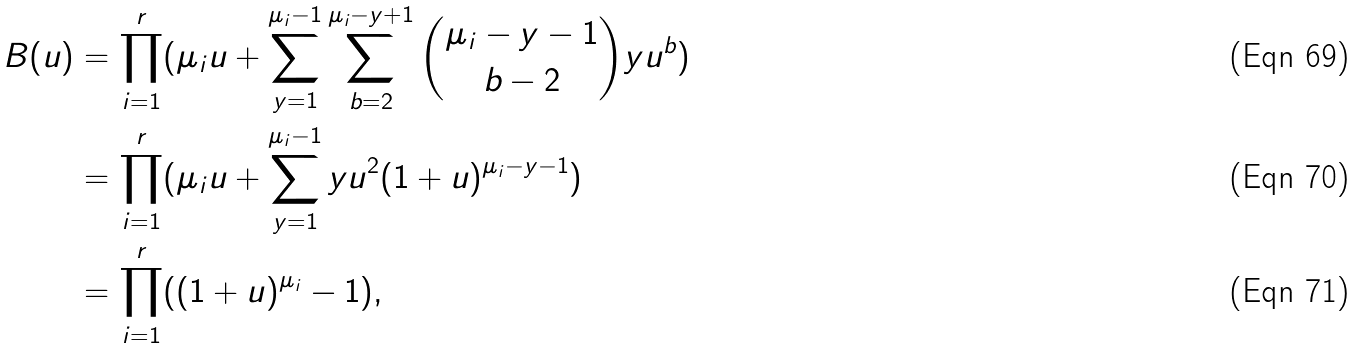Convert formula to latex. <formula><loc_0><loc_0><loc_500><loc_500>B ( u ) & = \prod _ { i = 1 } ^ { r } ( \mu _ { i } u + \sum _ { y = 1 } ^ { \mu _ { i } - 1 } \sum _ { b = 2 } ^ { \mu _ { i } - y + 1 } \binom { \mu _ { i } - y - 1 } { b - 2 } y u ^ { b } ) \\ & = \prod _ { i = 1 } ^ { r } ( \mu _ { i } u + \sum _ { y = 1 } ^ { \mu _ { i } - 1 } y u ^ { 2 } ( 1 + u ) ^ { \mu _ { i } - y - 1 } ) \\ & = \prod _ { i = 1 } ^ { r } ( ( 1 + u ) ^ { \mu _ { i } } - 1 ) ,</formula> 